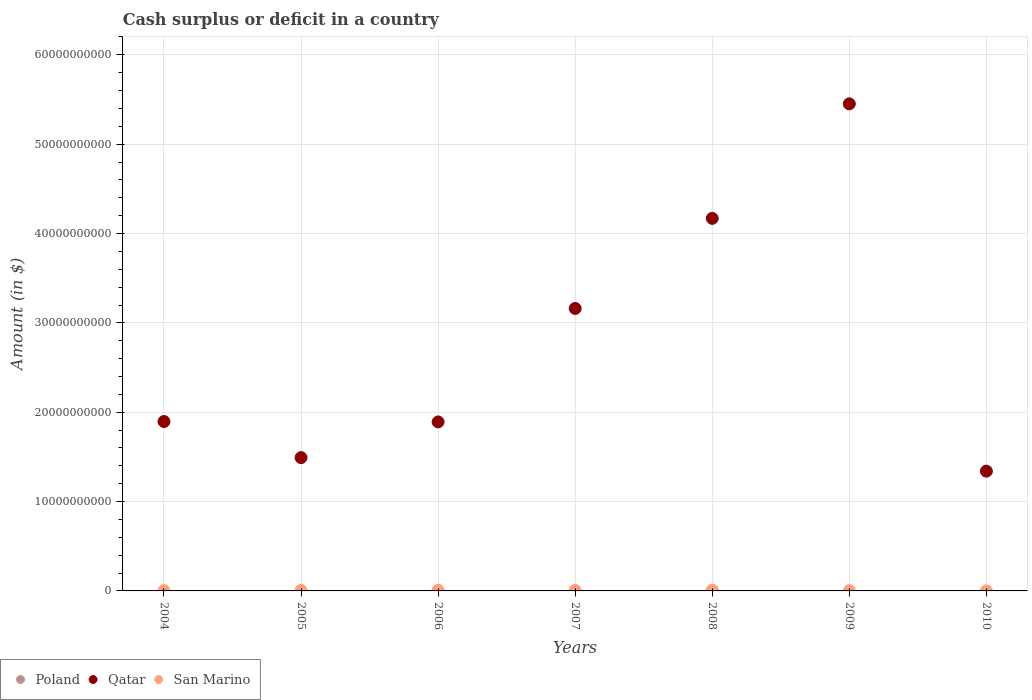What is the amount of cash surplus or deficit in Qatar in 2006?
Provide a short and direct response. 1.89e+1. Across all years, what is the maximum amount of cash surplus or deficit in Qatar?
Ensure brevity in your answer.  5.45e+1. What is the total amount of cash surplus or deficit in Poland in the graph?
Offer a terse response. 0. What is the difference between the amount of cash surplus or deficit in San Marino in 2004 and that in 2010?
Offer a very short reply. 2.43e+07. What is the difference between the amount of cash surplus or deficit in Qatar in 2005 and the amount of cash surplus or deficit in Poland in 2007?
Ensure brevity in your answer.  1.49e+1. What is the average amount of cash surplus or deficit in San Marino per year?
Your answer should be very brief. 4.77e+07. In the year 2008, what is the difference between the amount of cash surplus or deficit in San Marino and amount of cash surplus or deficit in Qatar?
Make the answer very short. -4.16e+1. In how many years, is the amount of cash surplus or deficit in San Marino greater than 28000000000 $?
Provide a short and direct response. 0. What is the ratio of the amount of cash surplus or deficit in Qatar in 2006 to that in 2007?
Your answer should be compact. 0.6. Is the difference between the amount of cash surplus or deficit in San Marino in 2007 and 2008 greater than the difference between the amount of cash surplus or deficit in Qatar in 2007 and 2008?
Your response must be concise. Yes. What is the difference between the highest and the second highest amount of cash surplus or deficit in Qatar?
Provide a short and direct response. 1.28e+1. What is the difference between the highest and the lowest amount of cash surplus or deficit in Qatar?
Your response must be concise. 4.11e+1. In how many years, is the amount of cash surplus or deficit in Poland greater than the average amount of cash surplus or deficit in Poland taken over all years?
Offer a very short reply. 0. Is the sum of the amount of cash surplus or deficit in Qatar in 2006 and 2009 greater than the maximum amount of cash surplus or deficit in San Marino across all years?
Provide a succinct answer. Yes. How many dotlines are there?
Give a very brief answer. 2. How many years are there in the graph?
Your response must be concise. 7. Are the values on the major ticks of Y-axis written in scientific E-notation?
Your answer should be compact. No. How many legend labels are there?
Offer a very short reply. 3. How are the legend labels stacked?
Ensure brevity in your answer.  Horizontal. What is the title of the graph?
Make the answer very short. Cash surplus or deficit in a country. Does "Chile" appear as one of the legend labels in the graph?
Your answer should be compact. No. What is the label or title of the X-axis?
Your answer should be compact. Years. What is the label or title of the Y-axis?
Your response must be concise. Amount (in $). What is the Amount (in $) of Qatar in 2004?
Offer a very short reply. 1.90e+1. What is the Amount (in $) in San Marino in 2004?
Your response must be concise. 2.59e+07. What is the Amount (in $) in Poland in 2005?
Provide a succinct answer. 0. What is the Amount (in $) in Qatar in 2005?
Keep it short and to the point. 1.49e+1. What is the Amount (in $) of San Marino in 2005?
Keep it short and to the point. 5.95e+07. What is the Amount (in $) in Qatar in 2006?
Your response must be concise. 1.89e+1. What is the Amount (in $) in San Marino in 2006?
Provide a succinct answer. 7.42e+07. What is the Amount (in $) in Qatar in 2007?
Provide a short and direct response. 3.16e+1. What is the Amount (in $) in San Marino in 2007?
Provide a succinct answer. 5.51e+07. What is the Amount (in $) in Qatar in 2008?
Offer a very short reply. 4.17e+1. What is the Amount (in $) in San Marino in 2008?
Keep it short and to the point. 8.90e+07. What is the Amount (in $) in Poland in 2009?
Provide a succinct answer. 0. What is the Amount (in $) of Qatar in 2009?
Offer a very short reply. 5.45e+1. What is the Amount (in $) of San Marino in 2009?
Provide a succinct answer. 2.83e+07. What is the Amount (in $) in Poland in 2010?
Offer a terse response. 0. What is the Amount (in $) in Qatar in 2010?
Ensure brevity in your answer.  1.34e+1. What is the Amount (in $) of San Marino in 2010?
Your answer should be compact. 1.52e+06. Across all years, what is the maximum Amount (in $) in Qatar?
Keep it short and to the point. 5.45e+1. Across all years, what is the maximum Amount (in $) in San Marino?
Offer a terse response. 8.90e+07. Across all years, what is the minimum Amount (in $) of Qatar?
Your answer should be very brief. 1.34e+1. Across all years, what is the minimum Amount (in $) in San Marino?
Your response must be concise. 1.52e+06. What is the total Amount (in $) in Qatar in the graph?
Your answer should be very brief. 1.94e+11. What is the total Amount (in $) in San Marino in the graph?
Ensure brevity in your answer.  3.34e+08. What is the difference between the Amount (in $) of Qatar in 2004 and that in 2005?
Keep it short and to the point. 4.04e+09. What is the difference between the Amount (in $) of San Marino in 2004 and that in 2005?
Keep it short and to the point. -3.36e+07. What is the difference between the Amount (in $) of Qatar in 2004 and that in 2006?
Make the answer very short. 4.60e+07. What is the difference between the Amount (in $) of San Marino in 2004 and that in 2006?
Ensure brevity in your answer.  -4.84e+07. What is the difference between the Amount (in $) of Qatar in 2004 and that in 2007?
Your response must be concise. -1.27e+1. What is the difference between the Amount (in $) of San Marino in 2004 and that in 2007?
Offer a terse response. -2.93e+07. What is the difference between the Amount (in $) of Qatar in 2004 and that in 2008?
Your answer should be very brief. -2.27e+1. What is the difference between the Amount (in $) in San Marino in 2004 and that in 2008?
Offer a terse response. -6.32e+07. What is the difference between the Amount (in $) of Qatar in 2004 and that in 2009?
Your answer should be very brief. -3.56e+1. What is the difference between the Amount (in $) in San Marino in 2004 and that in 2009?
Give a very brief answer. -2.44e+06. What is the difference between the Amount (in $) of Qatar in 2004 and that in 2010?
Make the answer very short. 5.55e+09. What is the difference between the Amount (in $) of San Marino in 2004 and that in 2010?
Offer a very short reply. 2.43e+07. What is the difference between the Amount (in $) of Qatar in 2005 and that in 2006?
Provide a short and direct response. -4.00e+09. What is the difference between the Amount (in $) of San Marino in 2005 and that in 2006?
Provide a succinct answer. -1.47e+07. What is the difference between the Amount (in $) in Qatar in 2005 and that in 2007?
Your answer should be very brief. -1.67e+1. What is the difference between the Amount (in $) of San Marino in 2005 and that in 2007?
Ensure brevity in your answer.  4.39e+06. What is the difference between the Amount (in $) of Qatar in 2005 and that in 2008?
Provide a succinct answer. -2.68e+1. What is the difference between the Amount (in $) of San Marino in 2005 and that in 2008?
Your answer should be very brief. -2.95e+07. What is the difference between the Amount (in $) of Qatar in 2005 and that in 2009?
Provide a short and direct response. -3.96e+1. What is the difference between the Amount (in $) in San Marino in 2005 and that in 2009?
Offer a terse response. 3.12e+07. What is the difference between the Amount (in $) of Qatar in 2005 and that in 2010?
Your answer should be very brief. 1.51e+09. What is the difference between the Amount (in $) in San Marino in 2005 and that in 2010?
Offer a very short reply. 5.80e+07. What is the difference between the Amount (in $) of Qatar in 2006 and that in 2007?
Give a very brief answer. -1.27e+1. What is the difference between the Amount (in $) in San Marino in 2006 and that in 2007?
Offer a very short reply. 1.91e+07. What is the difference between the Amount (in $) of Qatar in 2006 and that in 2008?
Ensure brevity in your answer.  -2.28e+1. What is the difference between the Amount (in $) of San Marino in 2006 and that in 2008?
Provide a succinct answer. -1.48e+07. What is the difference between the Amount (in $) in Qatar in 2006 and that in 2009?
Your answer should be very brief. -3.56e+1. What is the difference between the Amount (in $) of San Marino in 2006 and that in 2009?
Offer a terse response. 4.59e+07. What is the difference between the Amount (in $) in Qatar in 2006 and that in 2010?
Provide a succinct answer. 5.51e+09. What is the difference between the Amount (in $) of San Marino in 2006 and that in 2010?
Offer a terse response. 7.27e+07. What is the difference between the Amount (in $) in Qatar in 2007 and that in 2008?
Your response must be concise. -1.01e+1. What is the difference between the Amount (in $) in San Marino in 2007 and that in 2008?
Your response must be concise. -3.39e+07. What is the difference between the Amount (in $) in Qatar in 2007 and that in 2009?
Provide a short and direct response. -2.29e+1. What is the difference between the Amount (in $) in San Marino in 2007 and that in 2009?
Provide a short and direct response. 2.68e+07. What is the difference between the Amount (in $) of Qatar in 2007 and that in 2010?
Provide a succinct answer. 1.82e+1. What is the difference between the Amount (in $) of San Marino in 2007 and that in 2010?
Give a very brief answer. 5.36e+07. What is the difference between the Amount (in $) of Qatar in 2008 and that in 2009?
Provide a short and direct response. -1.28e+1. What is the difference between the Amount (in $) in San Marino in 2008 and that in 2009?
Your answer should be very brief. 6.07e+07. What is the difference between the Amount (in $) in Qatar in 2008 and that in 2010?
Your answer should be compact. 2.83e+1. What is the difference between the Amount (in $) of San Marino in 2008 and that in 2010?
Your answer should be very brief. 8.75e+07. What is the difference between the Amount (in $) of Qatar in 2009 and that in 2010?
Make the answer very short. 4.11e+1. What is the difference between the Amount (in $) in San Marino in 2009 and that in 2010?
Keep it short and to the point. 2.68e+07. What is the difference between the Amount (in $) in Qatar in 2004 and the Amount (in $) in San Marino in 2005?
Your response must be concise. 1.89e+1. What is the difference between the Amount (in $) of Qatar in 2004 and the Amount (in $) of San Marino in 2006?
Offer a very short reply. 1.89e+1. What is the difference between the Amount (in $) in Qatar in 2004 and the Amount (in $) in San Marino in 2007?
Keep it short and to the point. 1.89e+1. What is the difference between the Amount (in $) in Qatar in 2004 and the Amount (in $) in San Marino in 2008?
Provide a succinct answer. 1.89e+1. What is the difference between the Amount (in $) of Qatar in 2004 and the Amount (in $) of San Marino in 2009?
Your answer should be compact. 1.89e+1. What is the difference between the Amount (in $) of Qatar in 2004 and the Amount (in $) of San Marino in 2010?
Give a very brief answer. 1.90e+1. What is the difference between the Amount (in $) in Qatar in 2005 and the Amount (in $) in San Marino in 2006?
Your response must be concise. 1.48e+1. What is the difference between the Amount (in $) of Qatar in 2005 and the Amount (in $) of San Marino in 2007?
Your response must be concise. 1.49e+1. What is the difference between the Amount (in $) of Qatar in 2005 and the Amount (in $) of San Marino in 2008?
Your answer should be very brief. 1.48e+1. What is the difference between the Amount (in $) of Qatar in 2005 and the Amount (in $) of San Marino in 2009?
Give a very brief answer. 1.49e+1. What is the difference between the Amount (in $) of Qatar in 2005 and the Amount (in $) of San Marino in 2010?
Make the answer very short. 1.49e+1. What is the difference between the Amount (in $) of Qatar in 2006 and the Amount (in $) of San Marino in 2007?
Ensure brevity in your answer.  1.89e+1. What is the difference between the Amount (in $) in Qatar in 2006 and the Amount (in $) in San Marino in 2008?
Keep it short and to the point. 1.88e+1. What is the difference between the Amount (in $) of Qatar in 2006 and the Amount (in $) of San Marino in 2009?
Keep it short and to the point. 1.89e+1. What is the difference between the Amount (in $) in Qatar in 2006 and the Amount (in $) in San Marino in 2010?
Your answer should be very brief. 1.89e+1. What is the difference between the Amount (in $) in Qatar in 2007 and the Amount (in $) in San Marino in 2008?
Your response must be concise. 3.15e+1. What is the difference between the Amount (in $) of Qatar in 2007 and the Amount (in $) of San Marino in 2009?
Provide a succinct answer. 3.16e+1. What is the difference between the Amount (in $) in Qatar in 2007 and the Amount (in $) in San Marino in 2010?
Provide a short and direct response. 3.16e+1. What is the difference between the Amount (in $) of Qatar in 2008 and the Amount (in $) of San Marino in 2009?
Your response must be concise. 4.17e+1. What is the difference between the Amount (in $) of Qatar in 2008 and the Amount (in $) of San Marino in 2010?
Your answer should be very brief. 4.17e+1. What is the difference between the Amount (in $) in Qatar in 2009 and the Amount (in $) in San Marino in 2010?
Offer a terse response. 5.45e+1. What is the average Amount (in $) of Poland per year?
Ensure brevity in your answer.  0. What is the average Amount (in $) of Qatar per year?
Make the answer very short. 2.77e+1. What is the average Amount (in $) in San Marino per year?
Offer a terse response. 4.77e+07. In the year 2004, what is the difference between the Amount (in $) in Qatar and Amount (in $) in San Marino?
Your response must be concise. 1.89e+1. In the year 2005, what is the difference between the Amount (in $) of Qatar and Amount (in $) of San Marino?
Give a very brief answer. 1.49e+1. In the year 2006, what is the difference between the Amount (in $) in Qatar and Amount (in $) in San Marino?
Ensure brevity in your answer.  1.88e+1. In the year 2007, what is the difference between the Amount (in $) in Qatar and Amount (in $) in San Marino?
Your response must be concise. 3.16e+1. In the year 2008, what is the difference between the Amount (in $) of Qatar and Amount (in $) of San Marino?
Offer a very short reply. 4.16e+1. In the year 2009, what is the difference between the Amount (in $) of Qatar and Amount (in $) of San Marino?
Offer a very short reply. 5.45e+1. In the year 2010, what is the difference between the Amount (in $) of Qatar and Amount (in $) of San Marino?
Your answer should be compact. 1.34e+1. What is the ratio of the Amount (in $) in Qatar in 2004 to that in 2005?
Give a very brief answer. 1.27. What is the ratio of the Amount (in $) of San Marino in 2004 to that in 2005?
Keep it short and to the point. 0.43. What is the ratio of the Amount (in $) in Qatar in 2004 to that in 2006?
Your response must be concise. 1. What is the ratio of the Amount (in $) of San Marino in 2004 to that in 2006?
Your answer should be compact. 0.35. What is the ratio of the Amount (in $) in Qatar in 2004 to that in 2007?
Your answer should be compact. 0.6. What is the ratio of the Amount (in $) of San Marino in 2004 to that in 2007?
Make the answer very short. 0.47. What is the ratio of the Amount (in $) in Qatar in 2004 to that in 2008?
Give a very brief answer. 0.45. What is the ratio of the Amount (in $) in San Marino in 2004 to that in 2008?
Ensure brevity in your answer.  0.29. What is the ratio of the Amount (in $) of Qatar in 2004 to that in 2009?
Offer a very short reply. 0.35. What is the ratio of the Amount (in $) in San Marino in 2004 to that in 2009?
Ensure brevity in your answer.  0.91. What is the ratio of the Amount (in $) of Qatar in 2004 to that in 2010?
Give a very brief answer. 1.41. What is the ratio of the Amount (in $) of San Marino in 2004 to that in 2010?
Your answer should be very brief. 16.99. What is the ratio of the Amount (in $) of Qatar in 2005 to that in 2006?
Ensure brevity in your answer.  0.79. What is the ratio of the Amount (in $) of San Marino in 2005 to that in 2006?
Provide a short and direct response. 0.8. What is the ratio of the Amount (in $) of Qatar in 2005 to that in 2007?
Offer a very short reply. 0.47. What is the ratio of the Amount (in $) of San Marino in 2005 to that in 2007?
Your answer should be compact. 1.08. What is the ratio of the Amount (in $) in Qatar in 2005 to that in 2008?
Provide a short and direct response. 0.36. What is the ratio of the Amount (in $) in San Marino in 2005 to that in 2008?
Your response must be concise. 0.67. What is the ratio of the Amount (in $) in Qatar in 2005 to that in 2009?
Provide a short and direct response. 0.27. What is the ratio of the Amount (in $) of San Marino in 2005 to that in 2009?
Offer a very short reply. 2.1. What is the ratio of the Amount (in $) of Qatar in 2005 to that in 2010?
Your answer should be very brief. 1.11. What is the ratio of the Amount (in $) of San Marino in 2005 to that in 2010?
Give a very brief answer. 39.09. What is the ratio of the Amount (in $) of Qatar in 2006 to that in 2007?
Offer a very short reply. 0.6. What is the ratio of the Amount (in $) in San Marino in 2006 to that in 2007?
Your answer should be very brief. 1.35. What is the ratio of the Amount (in $) in Qatar in 2006 to that in 2008?
Your answer should be very brief. 0.45. What is the ratio of the Amount (in $) of San Marino in 2006 to that in 2008?
Give a very brief answer. 0.83. What is the ratio of the Amount (in $) of Qatar in 2006 to that in 2009?
Offer a terse response. 0.35. What is the ratio of the Amount (in $) of San Marino in 2006 to that in 2009?
Your answer should be compact. 2.62. What is the ratio of the Amount (in $) of Qatar in 2006 to that in 2010?
Give a very brief answer. 1.41. What is the ratio of the Amount (in $) in San Marino in 2006 to that in 2010?
Give a very brief answer. 48.77. What is the ratio of the Amount (in $) of Qatar in 2007 to that in 2008?
Make the answer very short. 0.76. What is the ratio of the Amount (in $) in San Marino in 2007 to that in 2008?
Your answer should be very brief. 0.62. What is the ratio of the Amount (in $) in Qatar in 2007 to that in 2009?
Give a very brief answer. 0.58. What is the ratio of the Amount (in $) in San Marino in 2007 to that in 2009?
Your answer should be very brief. 1.95. What is the ratio of the Amount (in $) of Qatar in 2007 to that in 2010?
Offer a very short reply. 2.36. What is the ratio of the Amount (in $) of San Marino in 2007 to that in 2010?
Keep it short and to the point. 36.21. What is the ratio of the Amount (in $) in Qatar in 2008 to that in 2009?
Provide a short and direct response. 0.76. What is the ratio of the Amount (in $) of San Marino in 2008 to that in 2009?
Offer a very short reply. 3.15. What is the ratio of the Amount (in $) in Qatar in 2008 to that in 2010?
Make the answer very short. 3.11. What is the ratio of the Amount (in $) of San Marino in 2008 to that in 2010?
Make the answer very short. 58.48. What is the ratio of the Amount (in $) of Qatar in 2009 to that in 2010?
Offer a very short reply. 4.07. What is the ratio of the Amount (in $) of San Marino in 2009 to that in 2010?
Ensure brevity in your answer.  18.59. What is the difference between the highest and the second highest Amount (in $) in Qatar?
Keep it short and to the point. 1.28e+1. What is the difference between the highest and the second highest Amount (in $) of San Marino?
Your response must be concise. 1.48e+07. What is the difference between the highest and the lowest Amount (in $) of Qatar?
Your answer should be compact. 4.11e+1. What is the difference between the highest and the lowest Amount (in $) in San Marino?
Keep it short and to the point. 8.75e+07. 